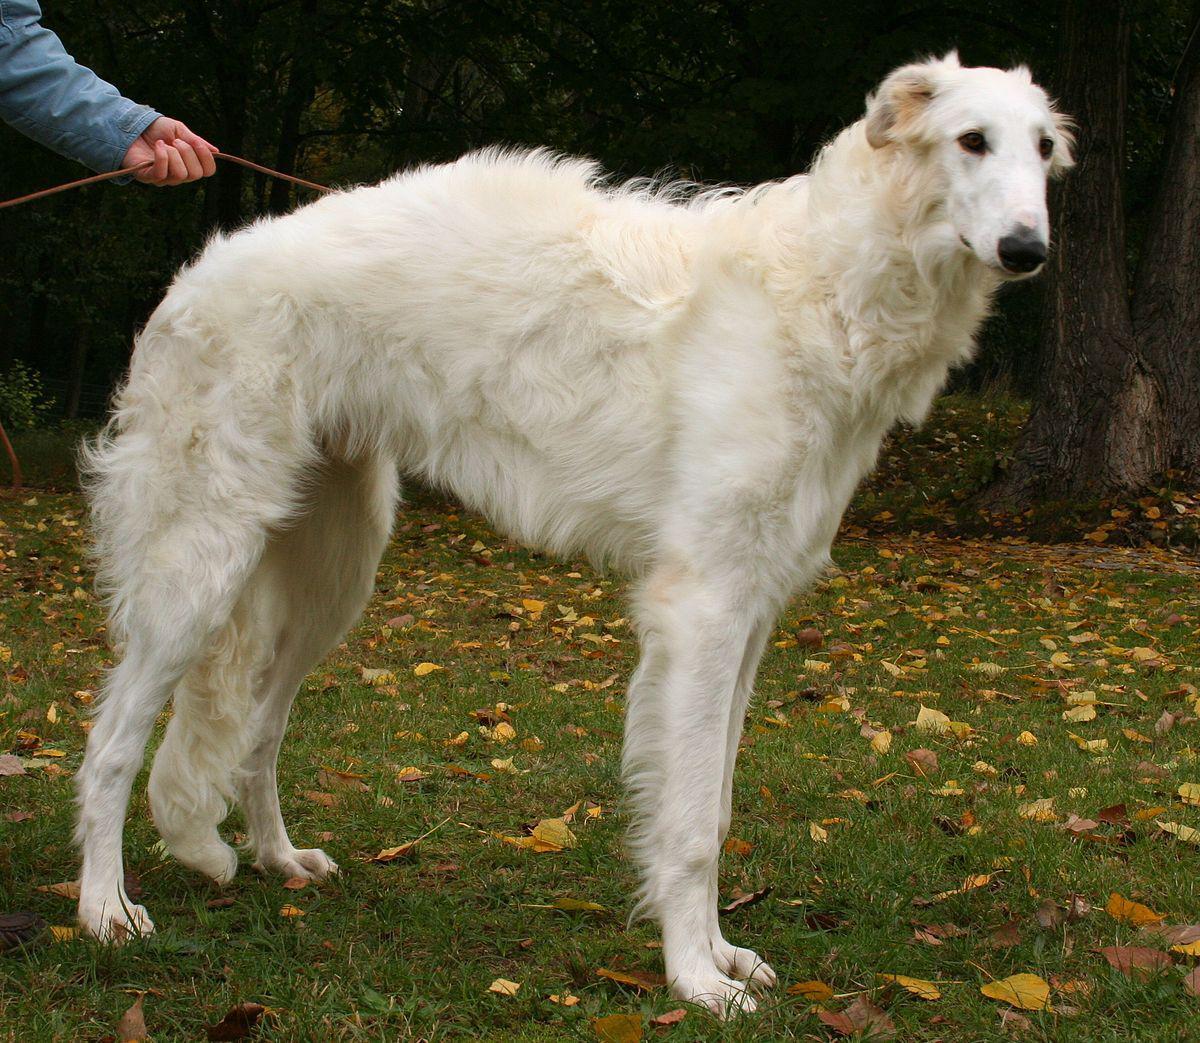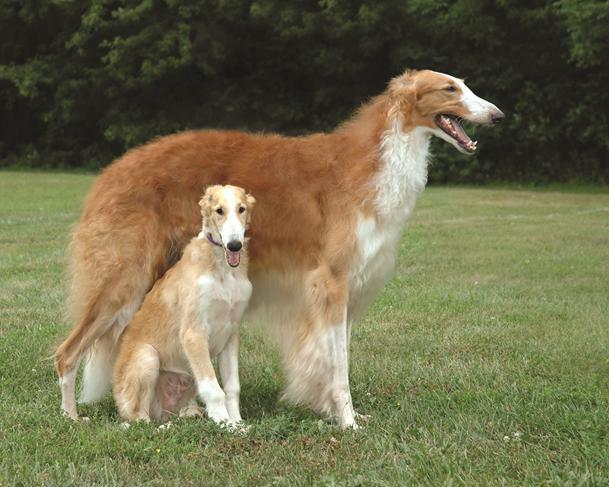The first image is the image on the left, the second image is the image on the right. Given the left and right images, does the statement "There are the same number of hounds in the left and right images." hold true? Answer yes or no. No. 